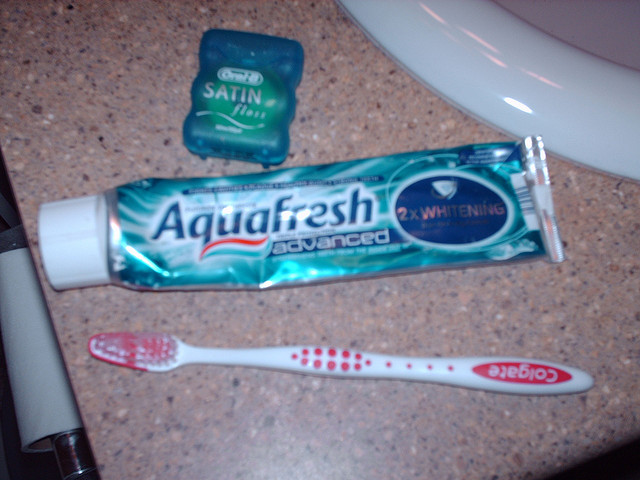<image>How much toilet paper is on the roll? It is uncertain how much toilet paper is on the roll. It can be very little to none. How much toilet paper is on the roll? I don't know how much toilet paper is on the roll. It can be very little or none. 